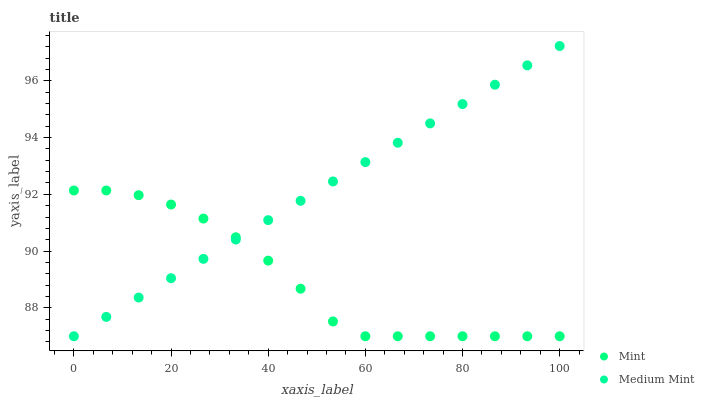Does Mint have the minimum area under the curve?
Answer yes or no. Yes. Does Medium Mint have the maximum area under the curve?
Answer yes or no. Yes. Does Mint have the maximum area under the curve?
Answer yes or no. No. Is Medium Mint the smoothest?
Answer yes or no. Yes. Is Mint the roughest?
Answer yes or no. Yes. Is Mint the smoothest?
Answer yes or no. No. Does Medium Mint have the lowest value?
Answer yes or no. Yes. Does Medium Mint have the highest value?
Answer yes or no. Yes. Does Mint have the highest value?
Answer yes or no. No. Does Mint intersect Medium Mint?
Answer yes or no. Yes. Is Mint less than Medium Mint?
Answer yes or no. No. Is Mint greater than Medium Mint?
Answer yes or no. No. 